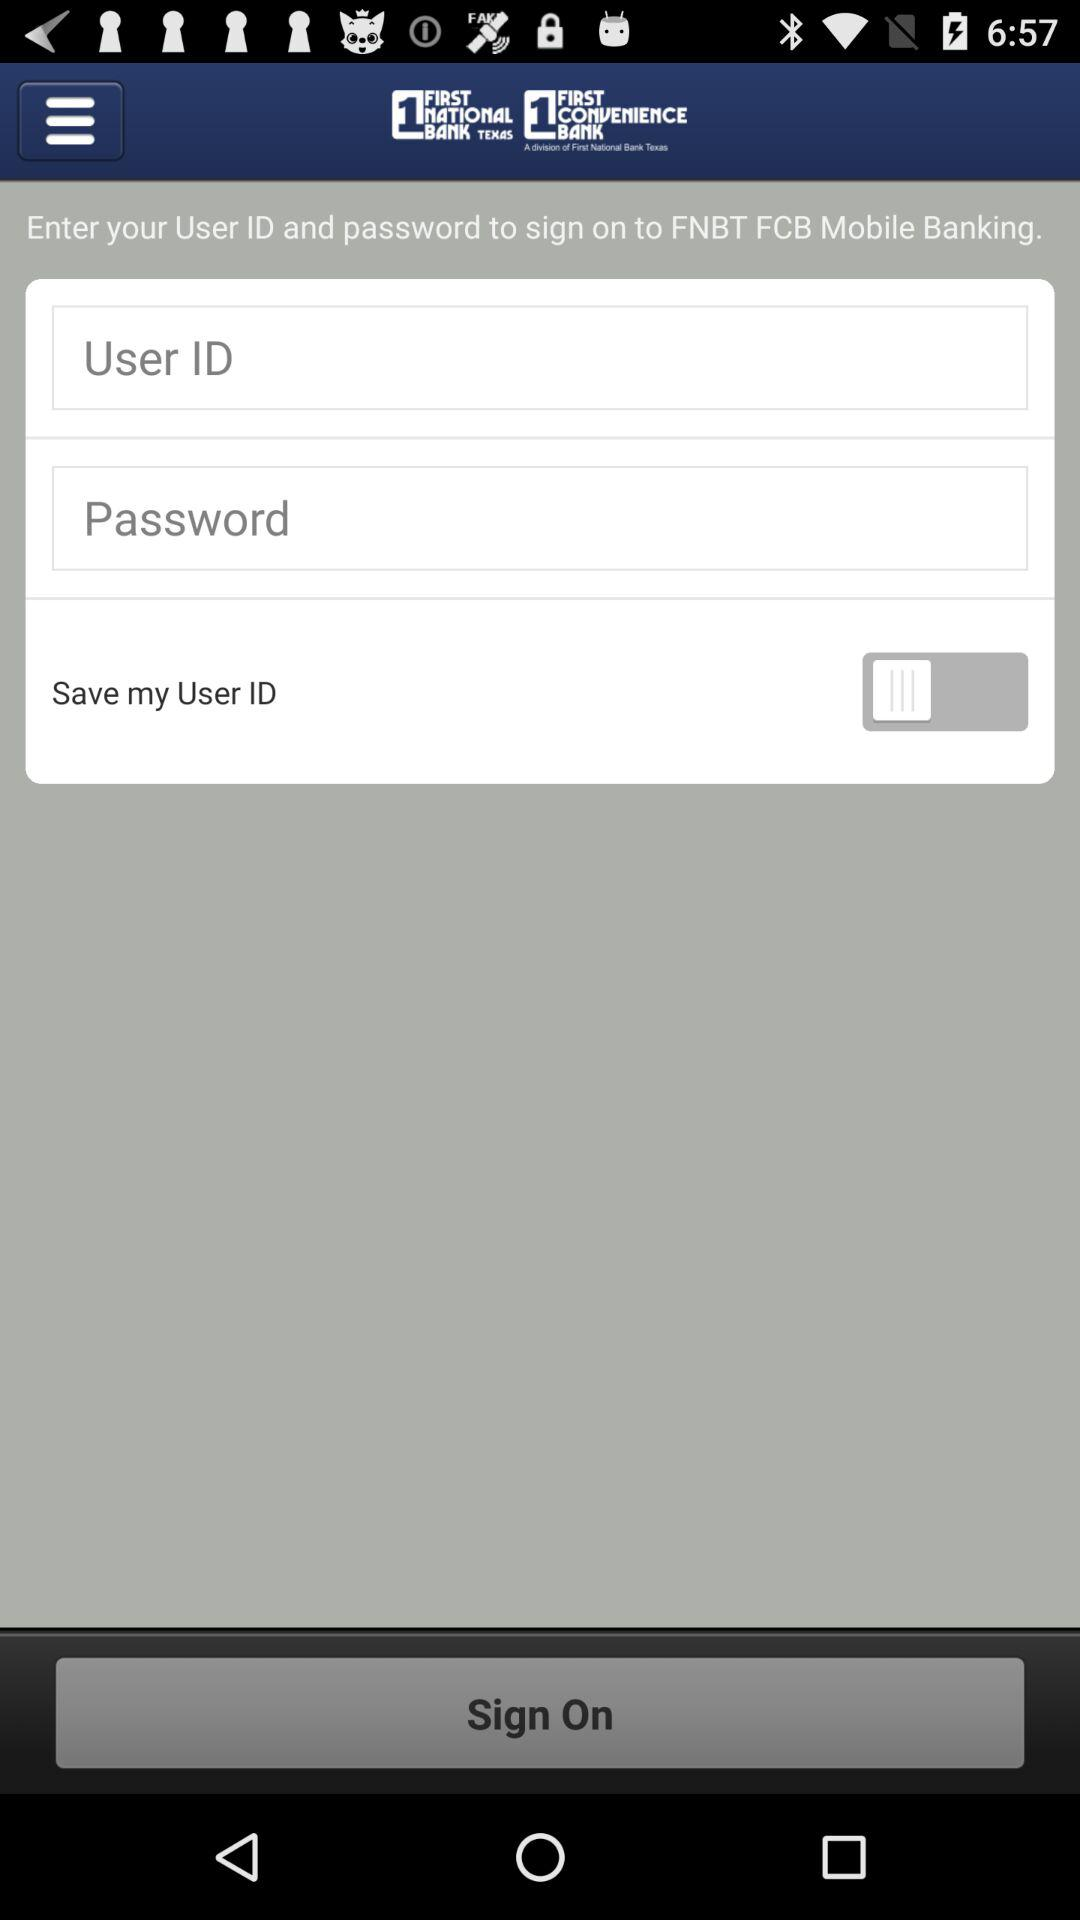How much does the user have in their bank account?
When the provided information is insufficient, respond with <no answer>. <no answer> 